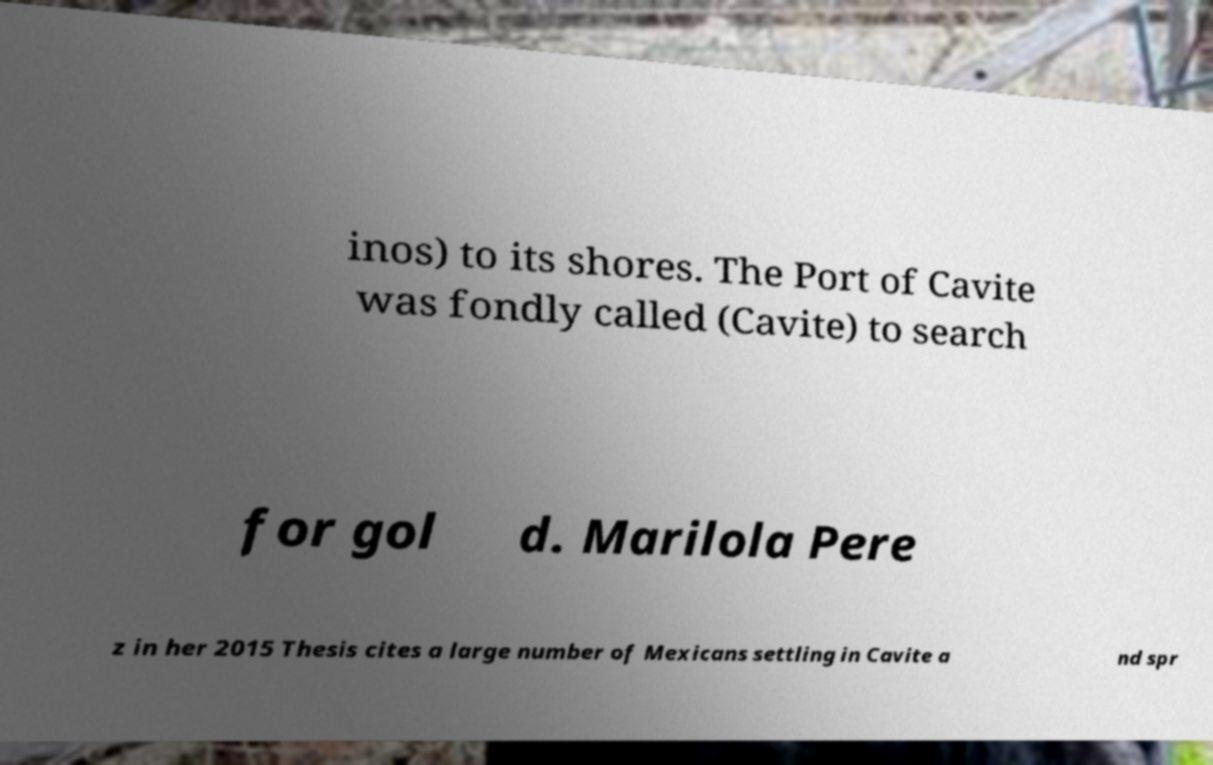Can you read and provide the text displayed in the image?This photo seems to have some interesting text. Can you extract and type it out for me? inos) to its shores. The Port of Cavite was fondly called (Cavite) to search for gol d. Marilola Pere z in her 2015 Thesis cites a large number of Mexicans settling in Cavite a nd spr 